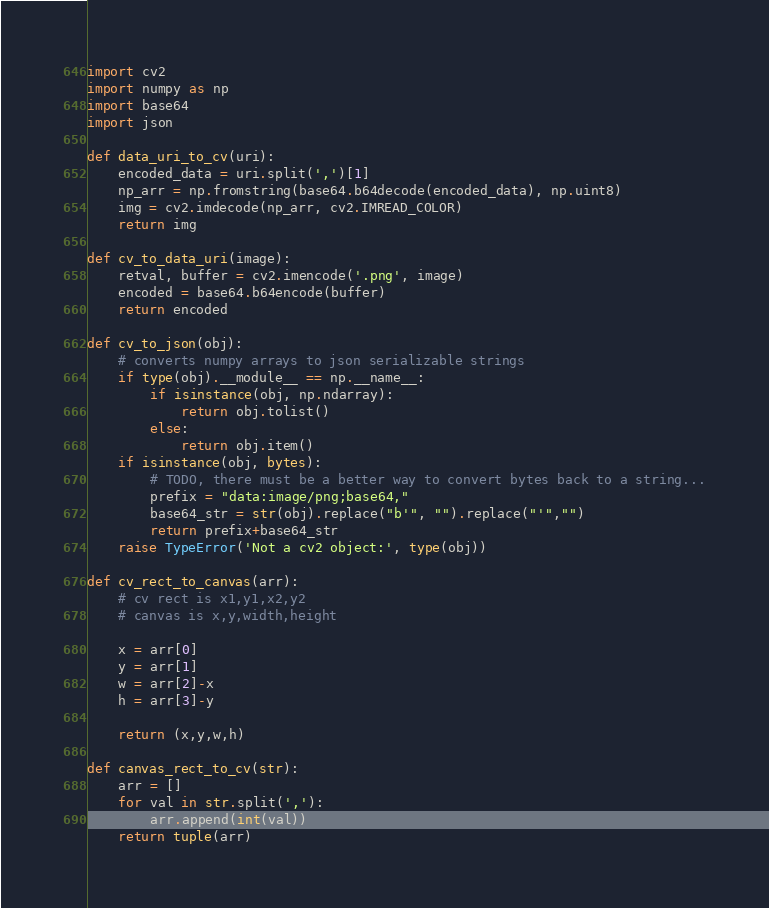<code> <loc_0><loc_0><loc_500><loc_500><_Python_>import cv2
import numpy as np
import base64
import json

def data_uri_to_cv(uri):
    encoded_data = uri.split(',')[1]
    np_arr = np.fromstring(base64.b64decode(encoded_data), np.uint8)
    img = cv2.imdecode(np_arr, cv2.IMREAD_COLOR)
    return img

def cv_to_data_uri(image):
    retval, buffer = cv2.imencode('.png', image)
    encoded = base64.b64encode(buffer)
    return encoded

def cv_to_json(obj):
    # converts numpy arrays to json serializable strings
    if type(obj).__module__ == np.__name__:
        if isinstance(obj, np.ndarray):
            return obj.tolist()
        else:
            return obj.item()
    if isinstance(obj, bytes):
        # TODO, there must be a better way to convert bytes back to a string...
        prefix = "data:image/png;base64,"
        base64_str = str(obj).replace("b'", "").replace("'","")
        return prefix+base64_str
    raise TypeError('Not a cv2 object:', type(obj))

def cv_rect_to_canvas(arr):
    # cv rect is x1,y1,x2,y2
    # canvas is x,y,width,height

    x = arr[0]
    y = arr[1]
    w = arr[2]-x
    h = arr[3]-y

    return (x,y,w,h)

def canvas_rect_to_cv(str):
    arr = []
    for val in str.split(','):
        arr.append(int(val))
    return tuple(arr)</code> 